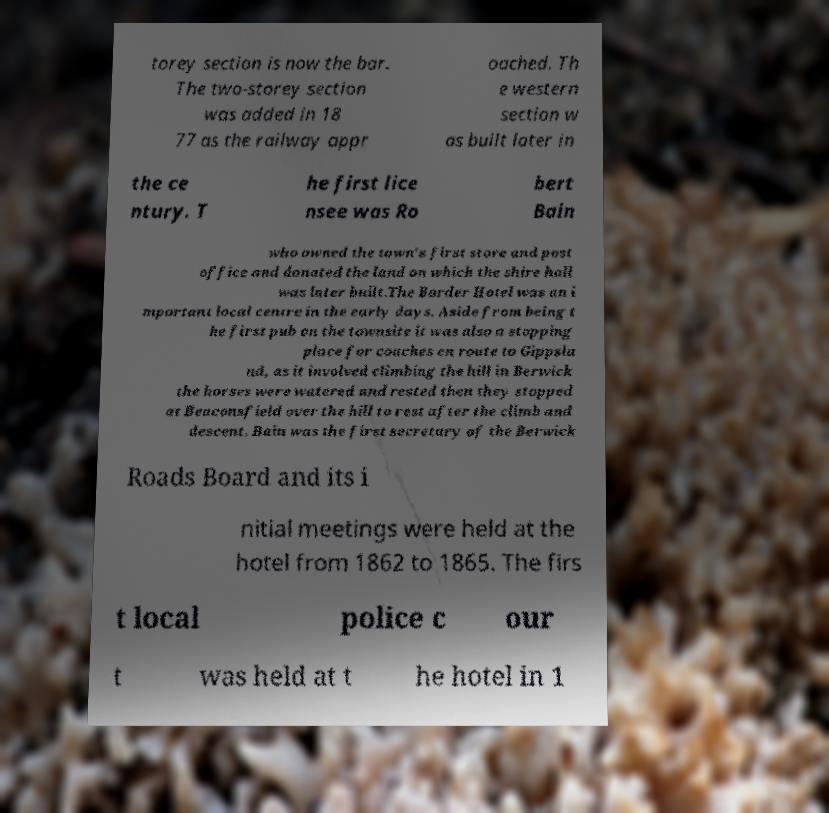Please identify and transcribe the text found in this image. torey section is now the bar. The two-storey section was added in 18 77 as the railway appr oached. Th e western section w as built later in the ce ntury. T he first lice nsee was Ro bert Bain who owned the town's first store and post office and donated the land on which the shire hall was later built.The Border Hotel was an i mportant local centre in the early days. Aside from being t he first pub on the townsite it was also a stopping place for coaches en route to Gippsla nd, as it involved climbing the hill in Berwick the horses were watered and rested then they stopped at Beaconsfield over the hill to rest after the climb and descent. Bain was the first secretary of the Berwick Roads Board and its i nitial meetings were held at the hotel from 1862 to 1865. The firs t local police c our t was held at t he hotel in 1 